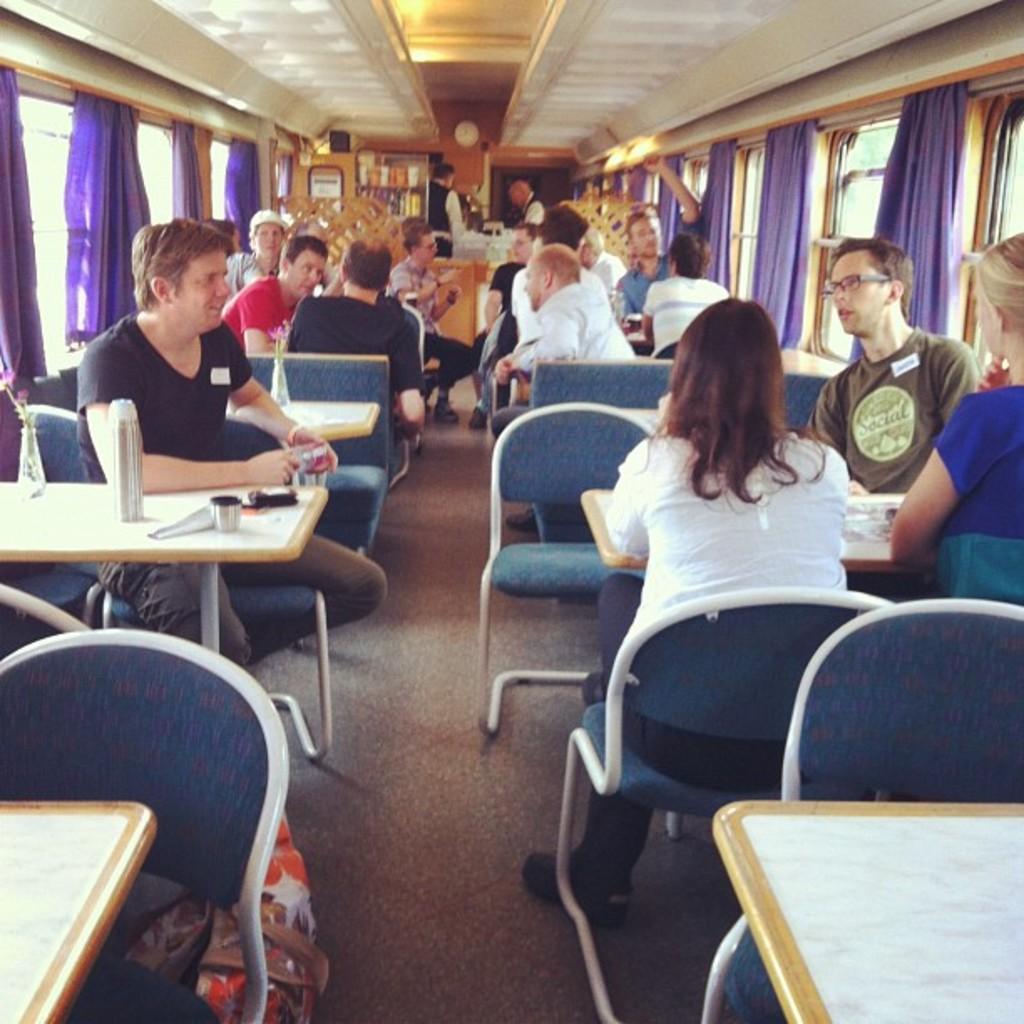In one or two sentences, can you explain what this image depicts? people are sitting on the chairs around the tables. left and right to them are windows on which purple curtains are present. at the back there are 2 waiters standing. 